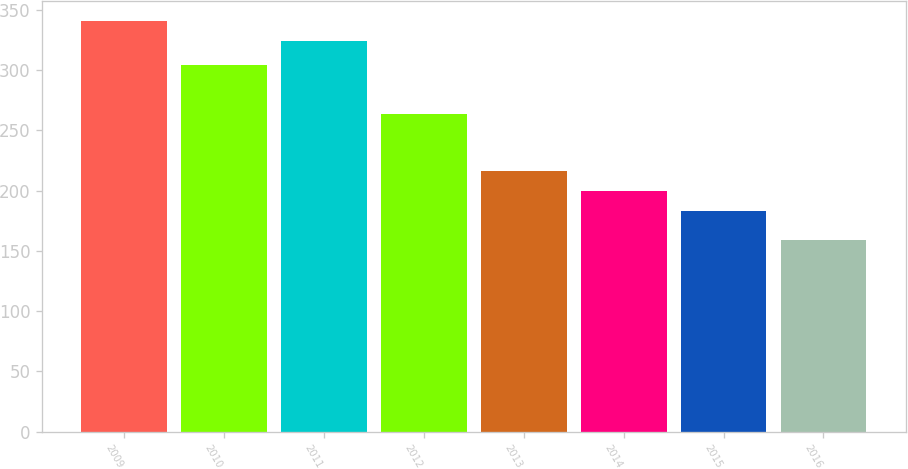Convert chart. <chart><loc_0><loc_0><loc_500><loc_500><bar_chart><fcel>2009<fcel>2010<fcel>2011<fcel>2012<fcel>2013<fcel>2014<fcel>2015<fcel>2016<nl><fcel>340.7<fcel>304<fcel>324<fcel>264<fcel>216.4<fcel>199.7<fcel>183<fcel>159<nl></chart> 